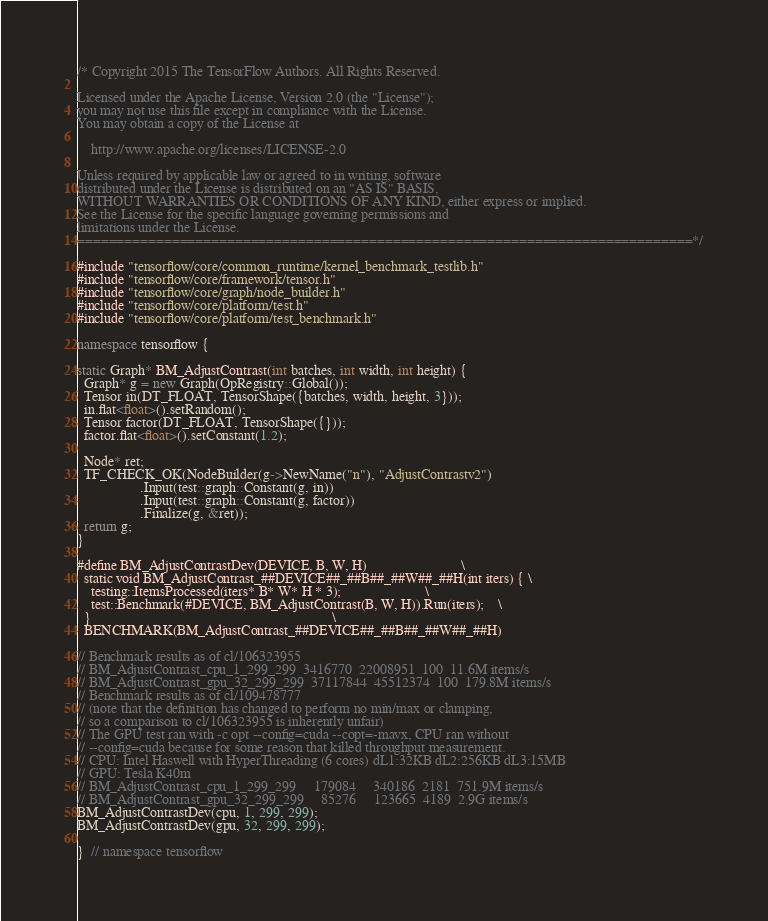<code> <loc_0><loc_0><loc_500><loc_500><_C++_>/* Copyright 2015 The TensorFlow Authors. All Rights Reserved.

Licensed under the Apache License, Version 2.0 (the "License");
you may not use this file except in compliance with the License.
You may obtain a copy of the License at

    http://www.apache.org/licenses/LICENSE-2.0

Unless required by applicable law or agreed to in writing, software
distributed under the License is distributed on an "AS IS" BASIS,
WITHOUT WARRANTIES OR CONDITIONS OF ANY KIND, either express or implied.
See the License for the specific language governing permissions and
limitations under the License.
==============================================================================*/

#include "tensorflow/core/common_runtime/kernel_benchmark_testlib.h"
#include "tensorflow/core/framework/tensor.h"
#include "tensorflow/core/graph/node_builder.h"
#include "tensorflow/core/platform/test.h"
#include "tensorflow/core/platform/test_benchmark.h"

namespace tensorflow {

static Graph* BM_AdjustContrast(int batches, int width, int height) {
  Graph* g = new Graph(OpRegistry::Global());
  Tensor in(DT_FLOAT, TensorShape({batches, width, height, 3}));
  in.flat<float>().setRandom();
  Tensor factor(DT_FLOAT, TensorShape({}));
  factor.flat<float>().setConstant(1.2);

  Node* ret;
  TF_CHECK_OK(NodeBuilder(g->NewName("n"), "AdjustContrastv2")
                  .Input(test::graph::Constant(g, in))
                  .Input(test::graph::Constant(g, factor))
                  .Finalize(g, &ret));
  return g;
}

#define BM_AdjustContrastDev(DEVICE, B, W, H)                           \
  static void BM_AdjustContrast_##DEVICE##_##B##_##W##_##H(int iters) { \
    testing::ItemsProcessed(iters* B* W* H * 3);                        \
    test::Benchmark(#DEVICE, BM_AdjustContrast(B, W, H)).Run(iters);    \
  }                                                                     \
  BENCHMARK(BM_AdjustContrast_##DEVICE##_##B##_##W##_##H)

// Benchmark results as of cl/106323955
// BM_AdjustContrast_cpu_1_299_299  3416770  22008951  100  11.6M items/s
// BM_AdjustContrast_gpu_32_299_299  37117844  45512374  100  179.8M items/s
// Benchmark results as of cl/109478777
// (note that the definition has changed to perform no min/max or clamping,
// so a comparison to cl/106323955 is inherently unfair)
// The GPU test ran with -c opt --config=cuda --copt=-mavx, CPU ran without
// --config=cuda because for some reason that killed throughput measurement.
// CPU: Intel Haswell with HyperThreading (6 cores) dL1:32KB dL2:256KB dL3:15MB
// GPU: Tesla K40m
// BM_AdjustContrast_cpu_1_299_299     179084     340186  2181  751.9M items/s
// BM_AdjustContrast_gpu_32_299_299     85276     123665  4189  2.9G items/s
BM_AdjustContrastDev(cpu, 1, 299, 299);
BM_AdjustContrastDev(gpu, 32, 299, 299);

}  // namespace tensorflow
</code> 